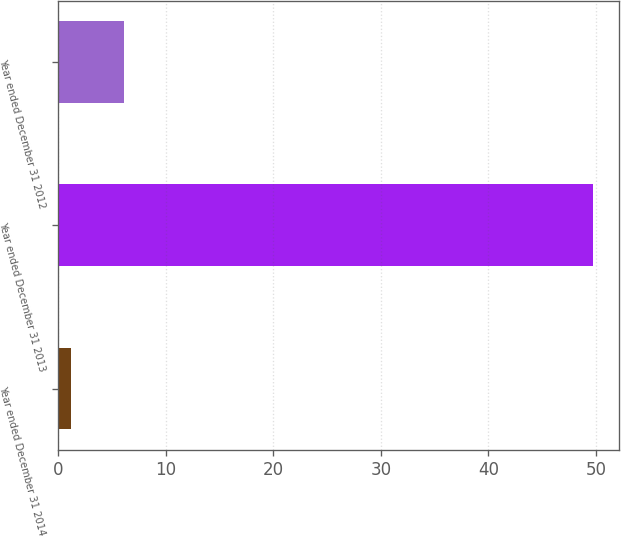Convert chart to OTSL. <chart><loc_0><loc_0><loc_500><loc_500><bar_chart><fcel>Year ended December 31 2014<fcel>Year ended December 31 2013<fcel>Year ended December 31 2012<nl><fcel>1.2<fcel>49.7<fcel>6.05<nl></chart> 